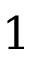Convert formula to latex. <formula><loc_0><loc_0><loc_500><loc_500>1</formula> 